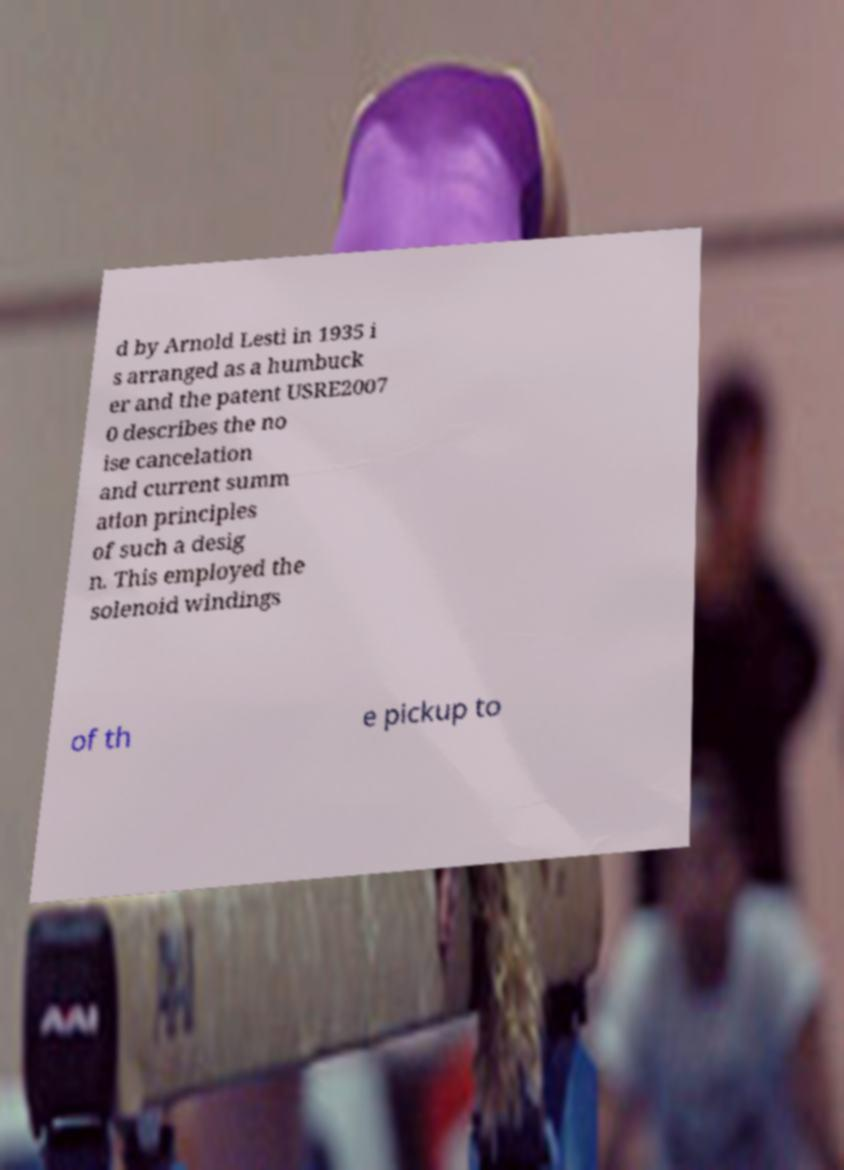I need the written content from this picture converted into text. Can you do that? d by Arnold Lesti in 1935 i s arranged as a humbuck er and the patent USRE2007 0 describes the no ise cancelation and current summ ation principles of such a desig n. This employed the solenoid windings of th e pickup to 